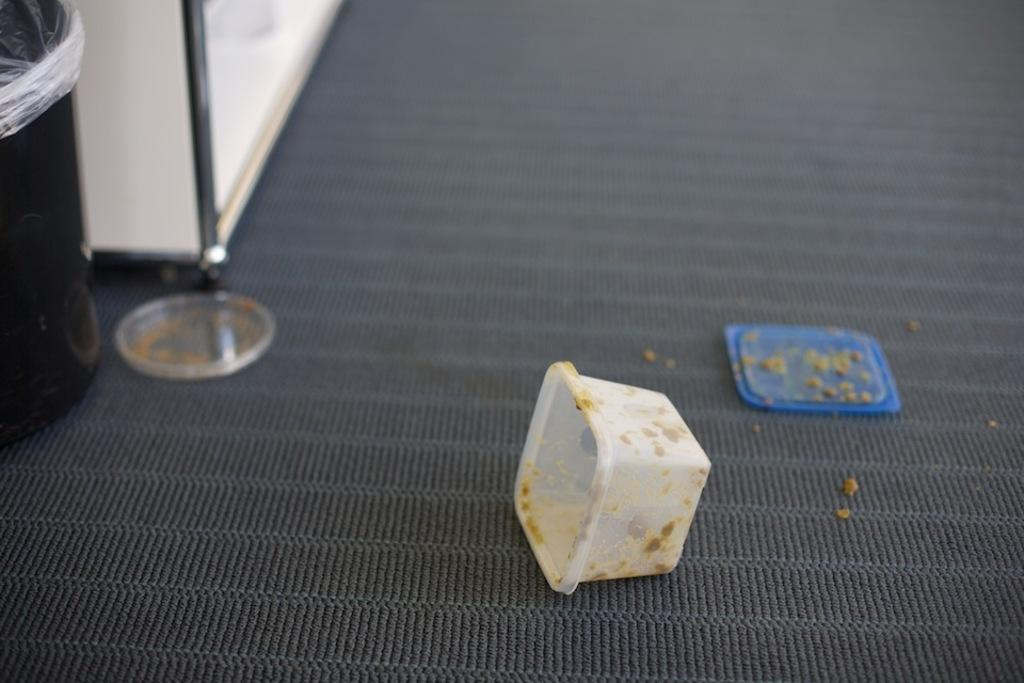What type of container is present in the image? There is a dustbin in the image. What other object can be seen in the image? There is a box in the image. Are there any covers or closures in the image? Yes, there are lids in the image. What is on the surface in the image? There is an object on the surface in the image. What type of zinc is visible in the image? There is no zinc present in the image. Can you see a swing in the image? There is no swing present in the image. 